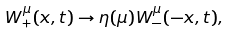Convert formula to latex. <formula><loc_0><loc_0><loc_500><loc_500>W _ { + } ^ { \mu } ( { x } , t ) \to \eta ( \mu ) W _ { - } ^ { \mu } ( { - x } , t ) ,</formula> 